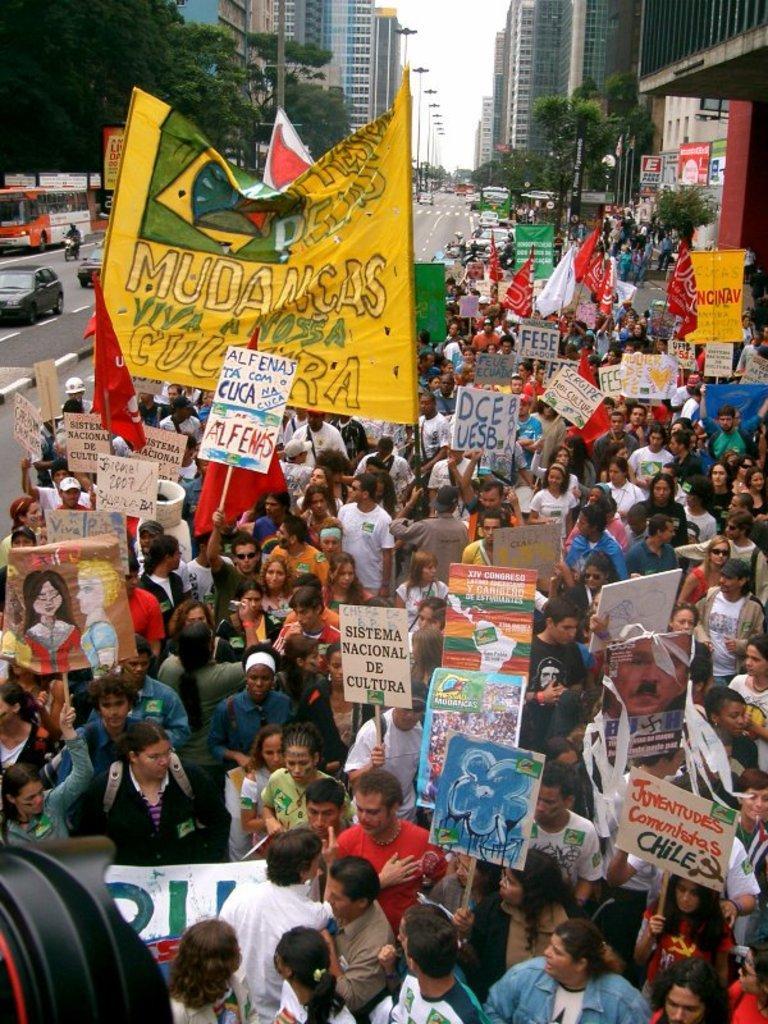Describe this image in one or two sentences. This picture shows a group of people standing and holding placards in their hands and we see buildings and trees and pole lights and we see few vehicles moving on the other side of the road. 